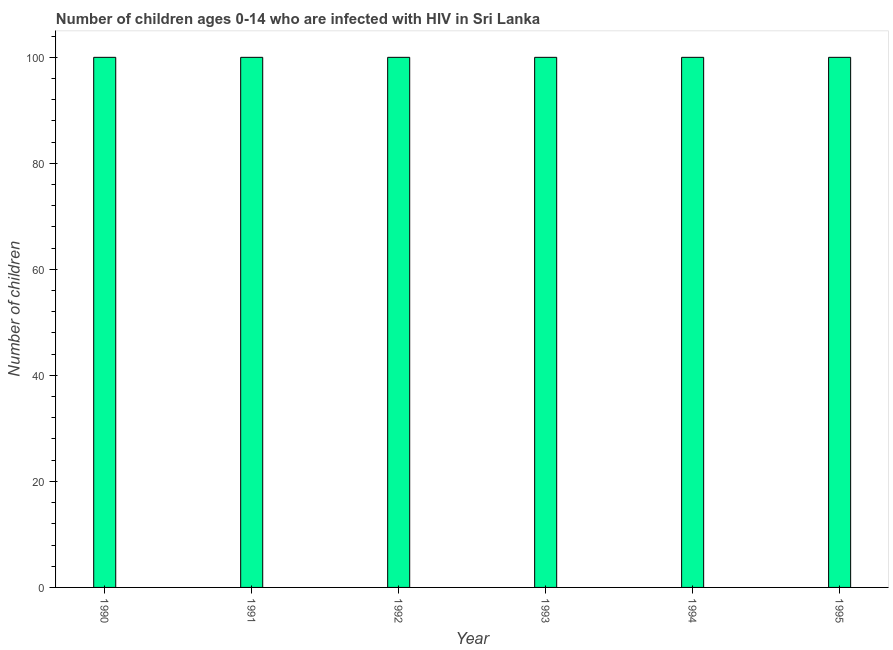What is the title of the graph?
Offer a terse response. Number of children ages 0-14 who are infected with HIV in Sri Lanka. What is the label or title of the Y-axis?
Ensure brevity in your answer.  Number of children. What is the number of children living with hiv in 1993?
Make the answer very short. 100. Across all years, what is the maximum number of children living with hiv?
Your answer should be very brief. 100. What is the sum of the number of children living with hiv?
Offer a very short reply. 600. What is the difference between the number of children living with hiv in 1991 and 1992?
Offer a terse response. 0. What is the average number of children living with hiv per year?
Your answer should be compact. 100. What is the median number of children living with hiv?
Provide a short and direct response. 100. Do a majority of the years between 1995 and 1994 (inclusive) have number of children living with hiv greater than 56 ?
Your answer should be very brief. No. What is the ratio of the number of children living with hiv in 1992 to that in 1994?
Your response must be concise. 1. Is the number of children living with hiv in 1991 less than that in 1994?
Your answer should be compact. No. Is the difference between the number of children living with hiv in 1991 and 1992 greater than the difference between any two years?
Provide a succinct answer. Yes. Is the sum of the number of children living with hiv in 1992 and 1995 greater than the maximum number of children living with hiv across all years?
Offer a very short reply. Yes. How many bars are there?
Provide a succinct answer. 6. Are all the bars in the graph horizontal?
Ensure brevity in your answer.  No. What is the difference between two consecutive major ticks on the Y-axis?
Keep it short and to the point. 20. Are the values on the major ticks of Y-axis written in scientific E-notation?
Provide a succinct answer. No. What is the Number of children of 1995?
Your answer should be very brief. 100. What is the difference between the Number of children in 1990 and 1991?
Provide a succinct answer. 0. What is the difference between the Number of children in 1990 and 1994?
Offer a very short reply. 0. What is the difference between the Number of children in 1990 and 1995?
Provide a short and direct response. 0. What is the difference between the Number of children in 1991 and 1993?
Give a very brief answer. 0. What is the difference between the Number of children in 1991 and 1995?
Your answer should be very brief. 0. What is the difference between the Number of children in 1992 and 1993?
Offer a very short reply. 0. What is the difference between the Number of children in 1992 and 1995?
Provide a short and direct response. 0. What is the difference between the Number of children in 1993 and 1994?
Give a very brief answer. 0. What is the ratio of the Number of children in 1990 to that in 1992?
Give a very brief answer. 1. What is the ratio of the Number of children in 1990 to that in 1993?
Offer a very short reply. 1. What is the ratio of the Number of children in 1990 to that in 1995?
Keep it short and to the point. 1. What is the ratio of the Number of children in 1991 to that in 1992?
Your answer should be compact. 1. What is the ratio of the Number of children in 1991 to that in 1994?
Make the answer very short. 1. What is the ratio of the Number of children in 1991 to that in 1995?
Ensure brevity in your answer.  1. What is the ratio of the Number of children in 1992 to that in 1995?
Make the answer very short. 1. What is the ratio of the Number of children in 1994 to that in 1995?
Provide a short and direct response. 1. 